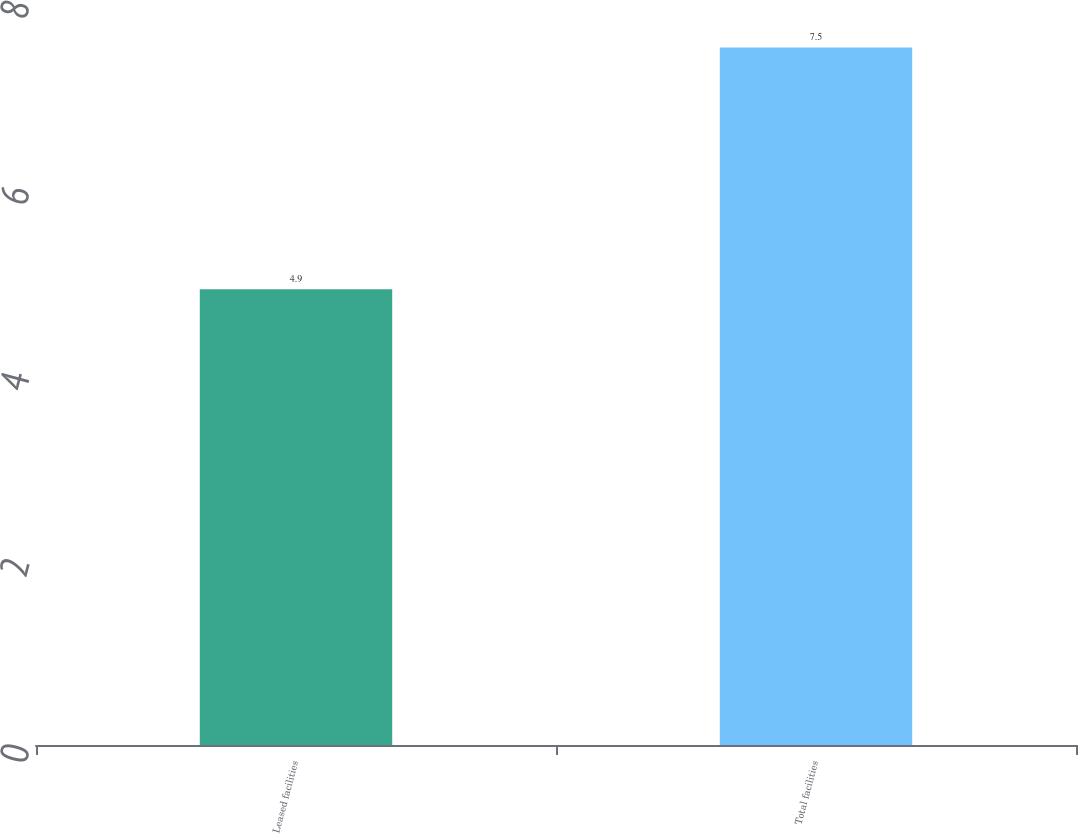<chart> <loc_0><loc_0><loc_500><loc_500><bar_chart><fcel>Leased facilities<fcel>Total facilities<nl><fcel>4.9<fcel>7.5<nl></chart> 